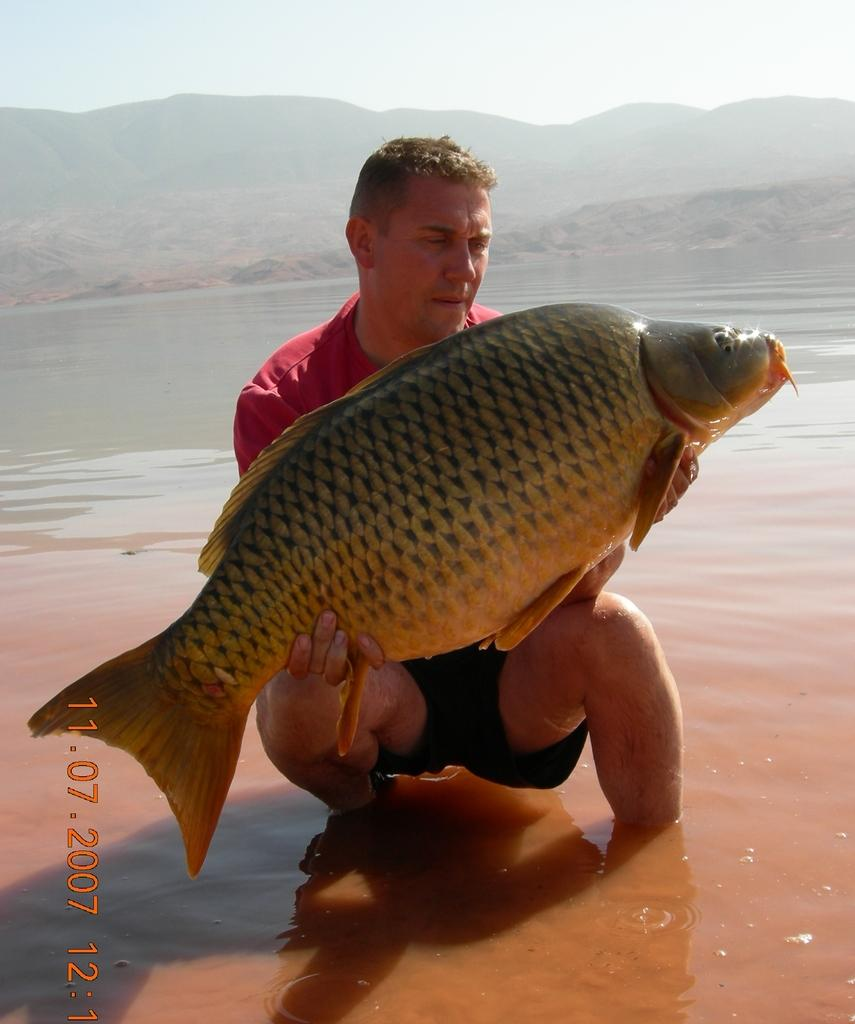What is the person holding in the image? The person is holding a fish. What can be seen in the background of the image? There are mountains in the distance. What is the primary element visible in the image? Water is visible in the image. What type of mint can be seen growing near the water in the image? There is no mint visible in the image; it only features a person holding a fish and mountains in the distance. 